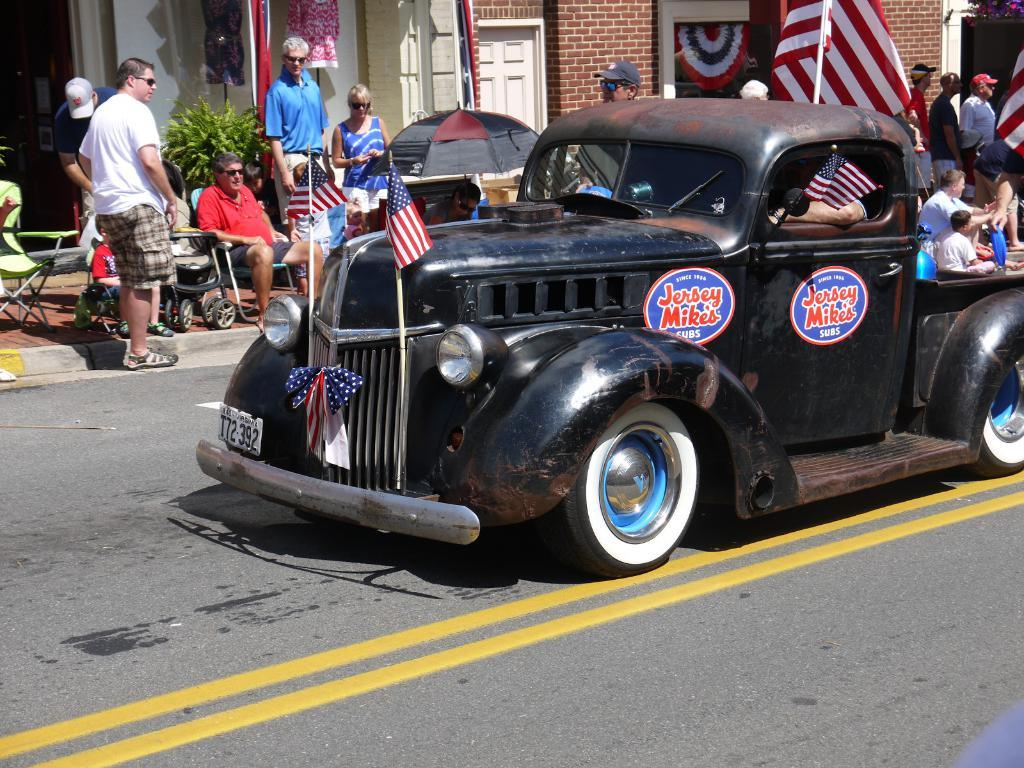What is the main subject of the image? The main subject of the image is a car. What is happening inside the car? People are sitting inside the car. What is happening on the footpath near the car? There are people on the footpath, some sitting and others standing. What type of meal is being served on the car's roof in the image? There is no meal being served on the car's roof in the image. 